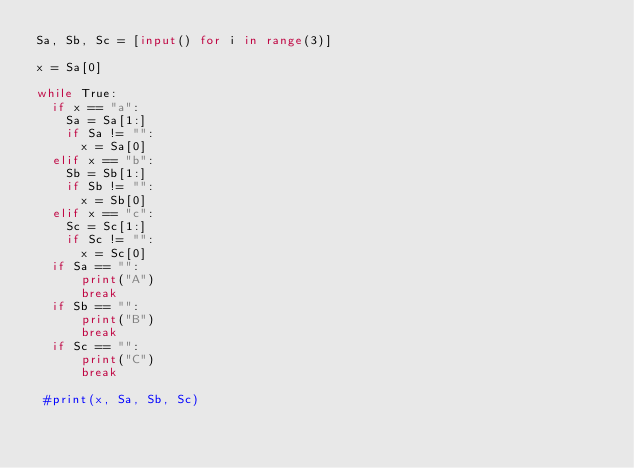Convert code to text. <code><loc_0><loc_0><loc_500><loc_500><_Python_>Sa, Sb, Sc = [input() for i in range(3)]

x = Sa[0]

while True:
  if x == "a":
    Sa = Sa[1:]
    if Sa != "":
      x = Sa[0]
  elif x == "b":
    Sb = Sb[1:]
    if Sb != "":
      x = Sb[0]
  elif x == "c":
    Sc = Sc[1:]
    if Sc != "":
      x = Sc[0]
  if Sa == "":
      print("A")
      break
  if Sb == "":
      print("B")
      break
  if Sc == "":
      print("C")
      break
 
 #print(x, Sa, Sb, Sc)</code> 